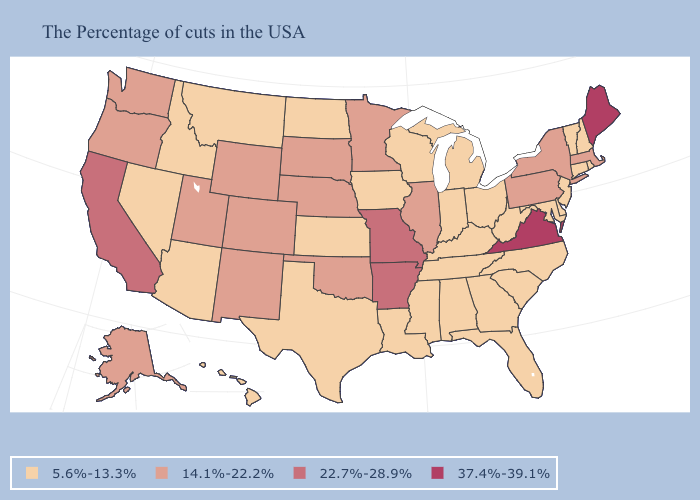Which states have the lowest value in the USA?
Write a very short answer. Rhode Island, New Hampshire, Vermont, Connecticut, New Jersey, Delaware, Maryland, North Carolina, South Carolina, West Virginia, Ohio, Florida, Georgia, Michigan, Kentucky, Indiana, Alabama, Tennessee, Wisconsin, Mississippi, Louisiana, Iowa, Kansas, Texas, North Dakota, Montana, Arizona, Idaho, Nevada, Hawaii. What is the value of Oklahoma?
Quick response, please. 14.1%-22.2%. Does Virginia have the highest value in the South?
Give a very brief answer. Yes. What is the value of Colorado?
Keep it brief. 14.1%-22.2%. Name the states that have a value in the range 37.4%-39.1%?
Give a very brief answer. Maine, Virginia. What is the value of Delaware?
Short answer required. 5.6%-13.3%. What is the value of Mississippi?
Quick response, please. 5.6%-13.3%. Does the map have missing data?
Quick response, please. No. Among the states that border California , which have the lowest value?
Give a very brief answer. Arizona, Nevada. What is the value of North Dakota?
Answer briefly. 5.6%-13.3%. Name the states that have a value in the range 22.7%-28.9%?
Give a very brief answer. Missouri, Arkansas, California. Name the states that have a value in the range 5.6%-13.3%?
Concise answer only. Rhode Island, New Hampshire, Vermont, Connecticut, New Jersey, Delaware, Maryland, North Carolina, South Carolina, West Virginia, Ohio, Florida, Georgia, Michigan, Kentucky, Indiana, Alabama, Tennessee, Wisconsin, Mississippi, Louisiana, Iowa, Kansas, Texas, North Dakota, Montana, Arizona, Idaho, Nevada, Hawaii. How many symbols are there in the legend?
Quick response, please. 4. Name the states that have a value in the range 14.1%-22.2%?
Give a very brief answer. Massachusetts, New York, Pennsylvania, Illinois, Minnesota, Nebraska, Oklahoma, South Dakota, Wyoming, Colorado, New Mexico, Utah, Washington, Oregon, Alaska. Does Wyoming have a higher value than Colorado?
Concise answer only. No. 